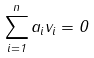Convert formula to latex. <formula><loc_0><loc_0><loc_500><loc_500>\sum _ { i = 1 } ^ { n } a _ { i } v _ { i } = 0</formula> 